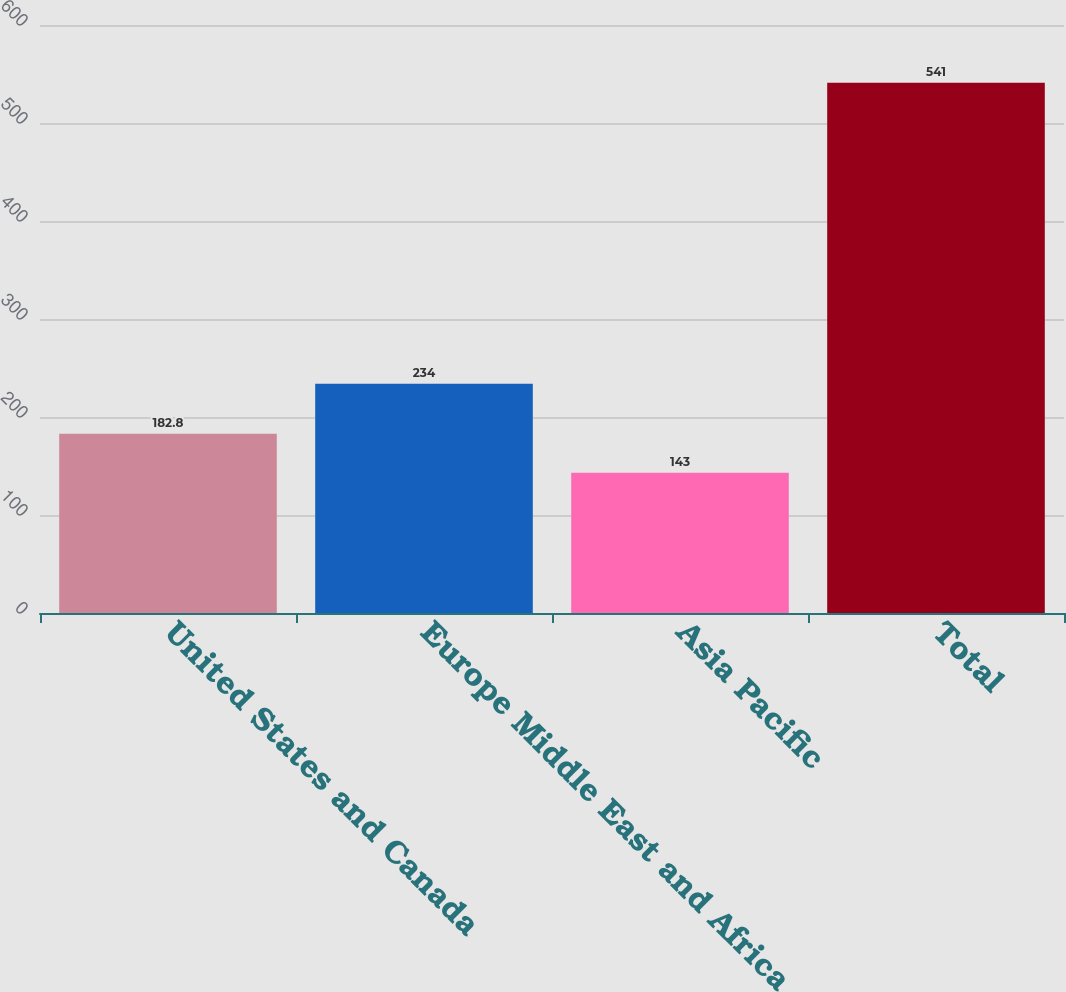Convert chart. <chart><loc_0><loc_0><loc_500><loc_500><bar_chart><fcel>United States and Canada<fcel>Europe Middle East and Africa<fcel>Asia Pacific<fcel>Total<nl><fcel>182.8<fcel>234<fcel>143<fcel>541<nl></chart> 